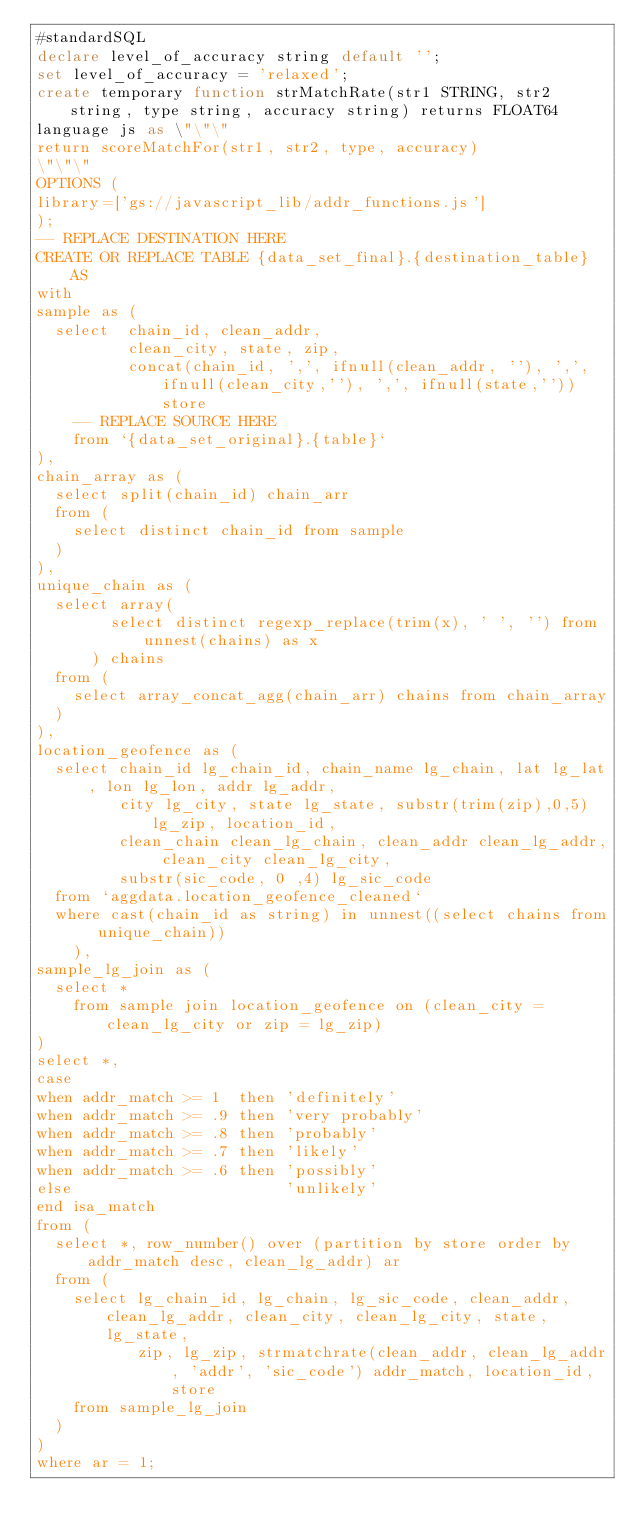Convert code to text. <code><loc_0><loc_0><loc_500><loc_500><_SQL_>#standardSQL
declare level_of_accuracy string default '';
set level_of_accuracy = 'relaxed';
create temporary function strMatchRate(str1 STRING, str2 string, type string, accuracy string) returns FLOAT64
language js as \"\"\"
return scoreMatchFor(str1, str2, type, accuracy)
\"\"\"
OPTIONS (
library=['gs://javascript_lib/addr_functions.js']
);
-- REPLACE DESTINATION HERE
CREATE OR REPLACE TABLE {data_set_final}.{destination_table} AS
with
sample as (
  select  chain_id, clean_addr,
          clean_city, state, zip,
          concat(chain_id, ',', ifnull(clean_addr, ''), ',', ifnull(clean_city,''), ',', ifnull(state,'')) store
    -- REPLACE SOURCE HERE
    from `{data_set_original}.{table}`
),
chain_array as (
  select split(chain_id) chain_arr
  from (
    select distinct chain_id from sample
  )
),
unique_chain as (
  select array(
        select distinct regexp_replace(trim(x), ' ', '') from unnest(chains) as x
      ) chains
  from (
    select array_concat_agg(chain_arr) chains from chain_array
  )
),
location_geofence as (
  select chain_id lg_chain_id, chain_name lg_chain, lat lg_lat, lon lg_lon, addr lg_addr,
         city lg_city, state lg_state, substr(trim(zip),0,5) lg_zip, location_id,
         clean_chain clean_lg_chain, clean_addr clean_lg_addr, clean_city clean_lg_city,
         substr(sic_code, 0 ,4) lg_sic_code
  from `aggdata.location_geofence_cleaned`
  where cast(chain_id as string) in unnest((select chains from unique_chain))
    ),
sample_lg_join as (
  select *
    from sample join location_geofence on (clean_city = clean_lg_city or zip = lg_zip)
)
select *,
case
when addr_match >= 1  then 'definitely'
when addr_match >= .9 then 'very probably'
when addr_match >= .8 then 'probably'
when addr_match >= .7 then 'likely'
when addr_match >= .6 then 'possibly'
else                       'unlikely'
end isa_match
from (
  select *, row_number() over (partition by store order by addr_match desc, clean_lg_addr) ar
  from (
    select lg_chain_id, lg_chain, lg_sic_code, clean_addr, clean_lg_addr, clean_city, clean_lg_city, state, lg_state,
           zip, lg_zip, strmatchrate(clean_addr, clean_lg_addr, 'addr', 'sic_code') addr_match, location_id, store
    from sample_lg_join
  )
)
where ar = 1;
</code> 